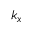Convert formula to latex. <formula><loc_0><loc_0><loc_500><loc_500>k _ { x }</formula> 